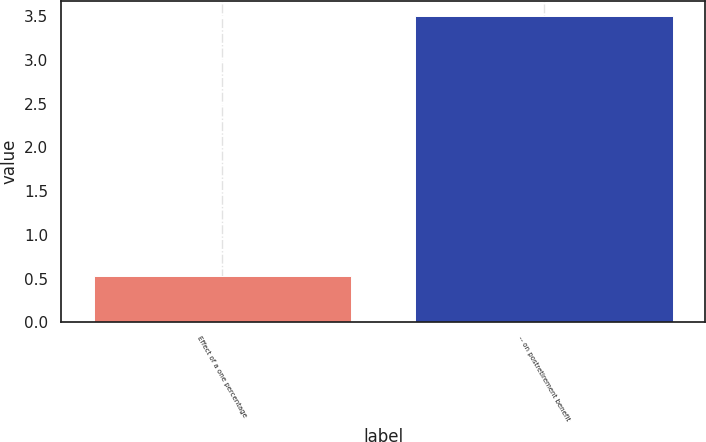Convert chart. <chart><loc_0><loc_0><loc_500><loc_500><bar_chart><fcel>Effect of a one percentage<fcel>-- on postretirement benefit<nl><fcel>0.53<fcel>3.5<nl></chart> 